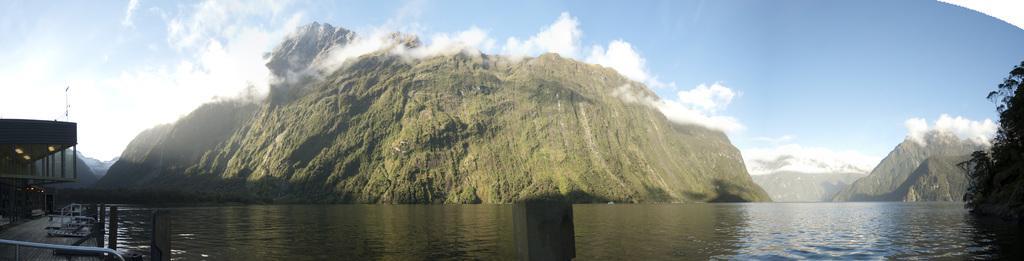Could you give a brief overview of what you see in this image? Here in this picture in the front we can see water present all over there and on the left side we can see a house present and we can see mountains present, that are covered with grass over there and we can also see plants present on the right side and we can see clouds present all over there 